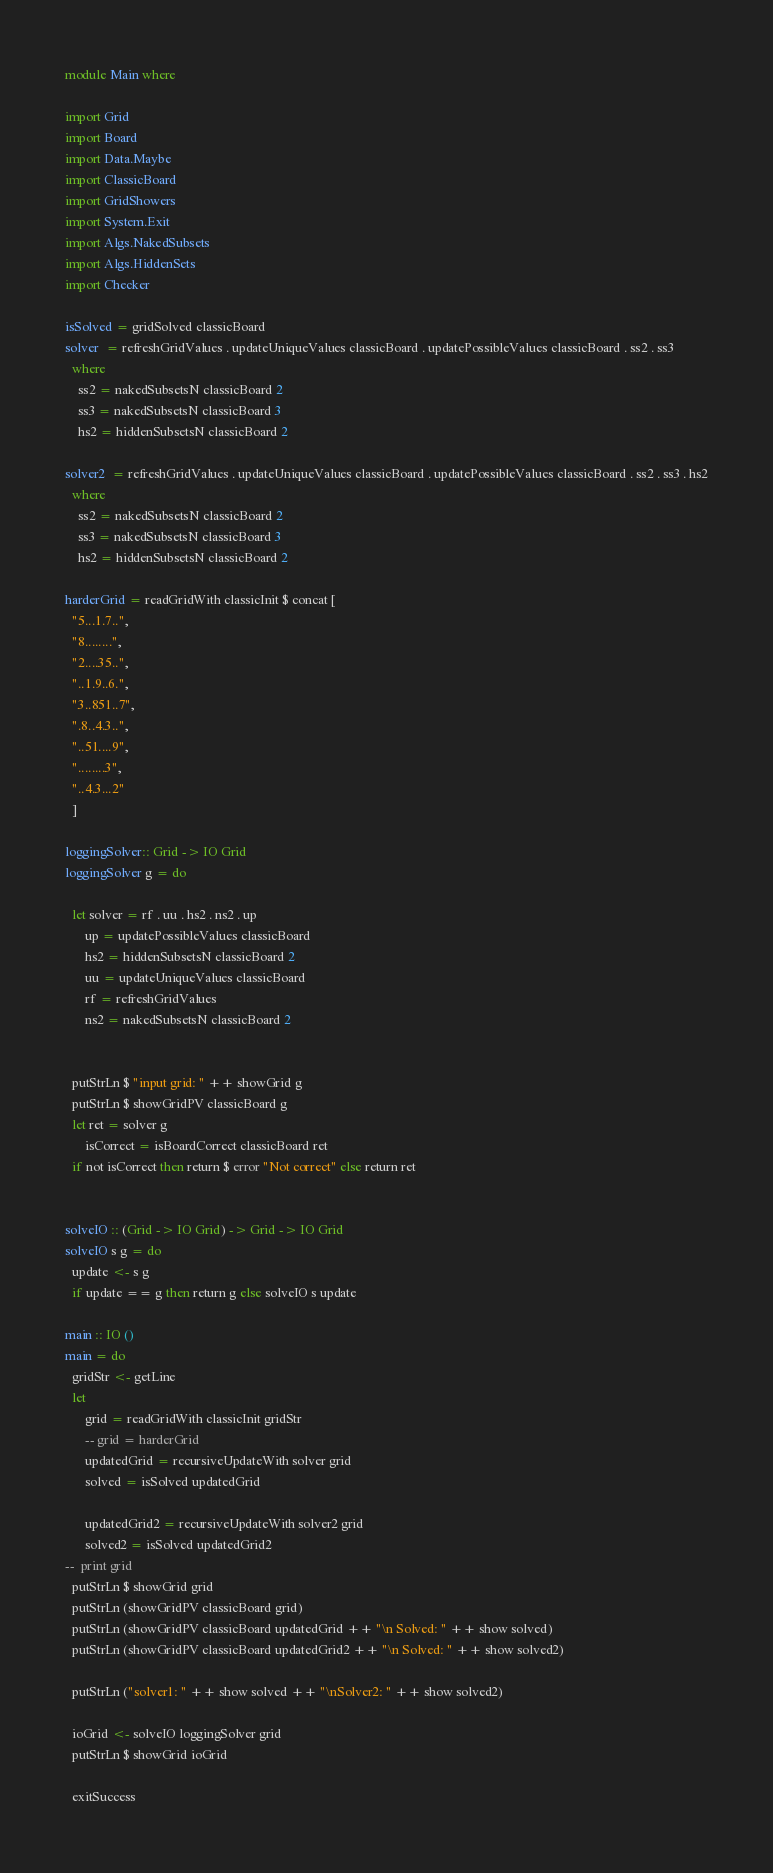<code> <loc_0><loc_0><loc_500><loc_500><_Haskell_>module Main where

import Grid
import Board
import Data.Maybe
import ClassicBoard
import GridShowers
import System.Exit
import Algs.NakedSubsets
import Algs.HiddenSets
import Checker

isSolved = gridSolved classicBoard
solver  = refreshGridValues . updateUniqueValues classicBoard . updatePossibleValues classicBoard . ss2 . ss3
  where
    ss2 = nakedSubsetsN classicBoard 2
    ss3 = nakedSubsetsN classicBoard 3
    hs2 = hiddenSubsetsN classicBoard 2

solver2  = refreshGridValues . updateUniqueValues classicBoard . updatePossibleValues classicBoard . ss2 . ss3 . hs2
  where
    ss2 = nakedSubsetsN classicBoard 2
    ss3 = nakedSubsetsN classicBoard 3
    hs2 = hiddenSubsetsN classicBoard 2

harderGrid = readGridWith classicInit $ concat [
  "5...1.7..",
  "8........",
  "2....35..",
  "..1.9..6.",
  "3..851..7",
  ".8..4.3..",
  "..51....9",
  "........3",
  "..4.3...2"
  ]

loggingSolver:: Grid -> IO Grid
loggingSolver g = do

  let solver = rf . uu . hs2 . ns2 . up
      up = updatePossibleValues classicBoard
      hs2 = hiddenSubsetsN classicBoard 2
      uu = updateUniqueValues classicBoard 
      rf = refreshGridValues
      ns2 = nakedSubsetsN classicBoard 2


  putStrLn $ "input grid: " ++ showGrid g
  putStrLn $ showGridPV classicBoard g
  let ret = solver g 
      isCorrect = isBoardCorrect classicBoard ret
  if not isCorrect then return $ error "Not correct" else return ret 

      
solveIO :: (Grid -> IO Grid) -> Grid -> IO Grid
solveIO s g = do
  update <- s g
  if update == g then return g else solveIO s update

main :: IO ()
main = do
  gridStr <- getLine
  let 
      grid = readGridWith classicInit gridStr
      -- grid = harderGrid
      updatedGrid = recursiveUpdateWith solver grid
      solved = isSolved updatedGrid

      updatedGrid2 = recursiveUpdateWith solver2 grid
      solved2 = isSolved updatedGrid2
--  print grid
  putStrLn $ showGrid grid
  putStrLn (showGridPV classicBoard grid)
  putStrLn (showGridPV classicBoard updatedGrid ++ "\n Solved: " ++ show solved)
  putStrLn (showGridPV classicBoard updatedGrid2 ++ "\n Solved: " ++ show solved2)

  putStrLn ("solver1: " ++ show solved ++ "\nSolver2: " ++ show solved2)

  ioGrid <- solveIO loggingSolver grid
  putStrLn $ showGrid ioGrid

  exitSuccess 


</code> 